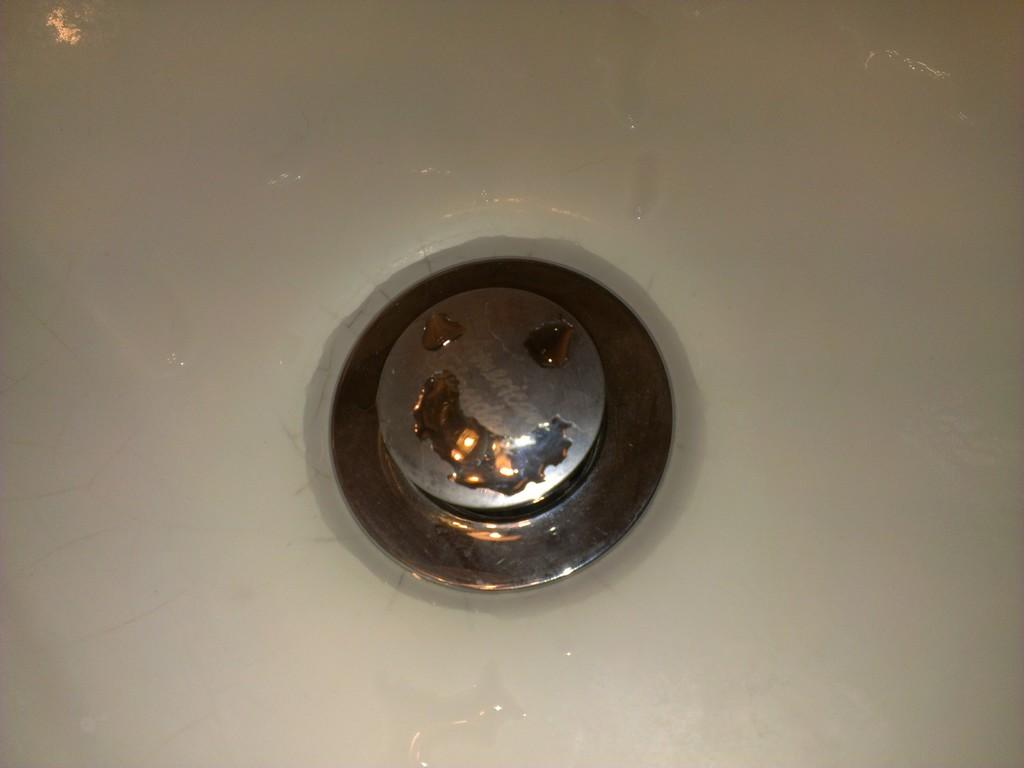What can be found in the image related to washing or cleaning? There is a sink in the image. What feature does the sink have? The sink has a drain. Is there any liquid present in the image? Yes, there is water on the sink. What type of grain is being processed in the sink in the image? There is no grain present in the image; it only features a sink with water and a drain. 